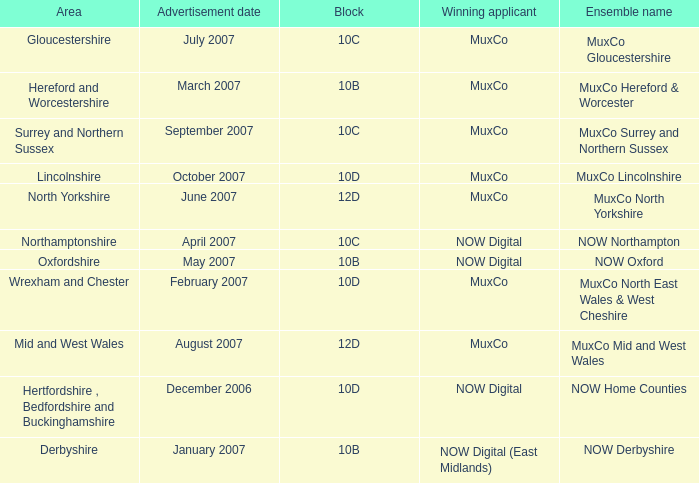What is Ensemble Name Muxco Gloucestershire's Advertisement Date in Block 10C? July 2007. 